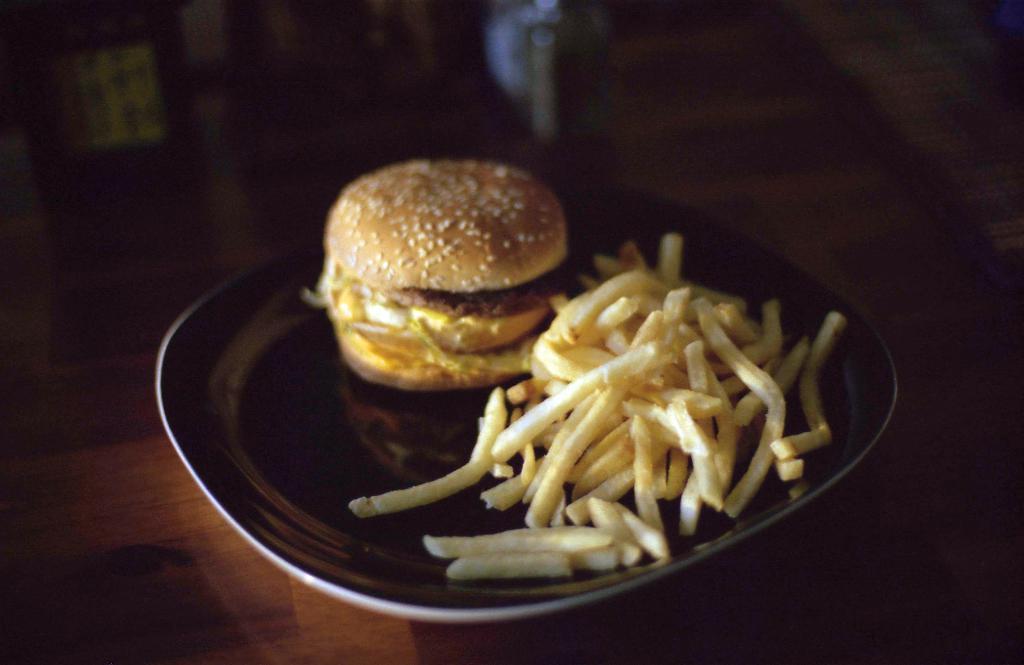Please provide a concise description of this image. In this image I see a plate on which there are french fries and I see a burger over here and this plate is on a brown color surface and it is a bit dark in the background. 